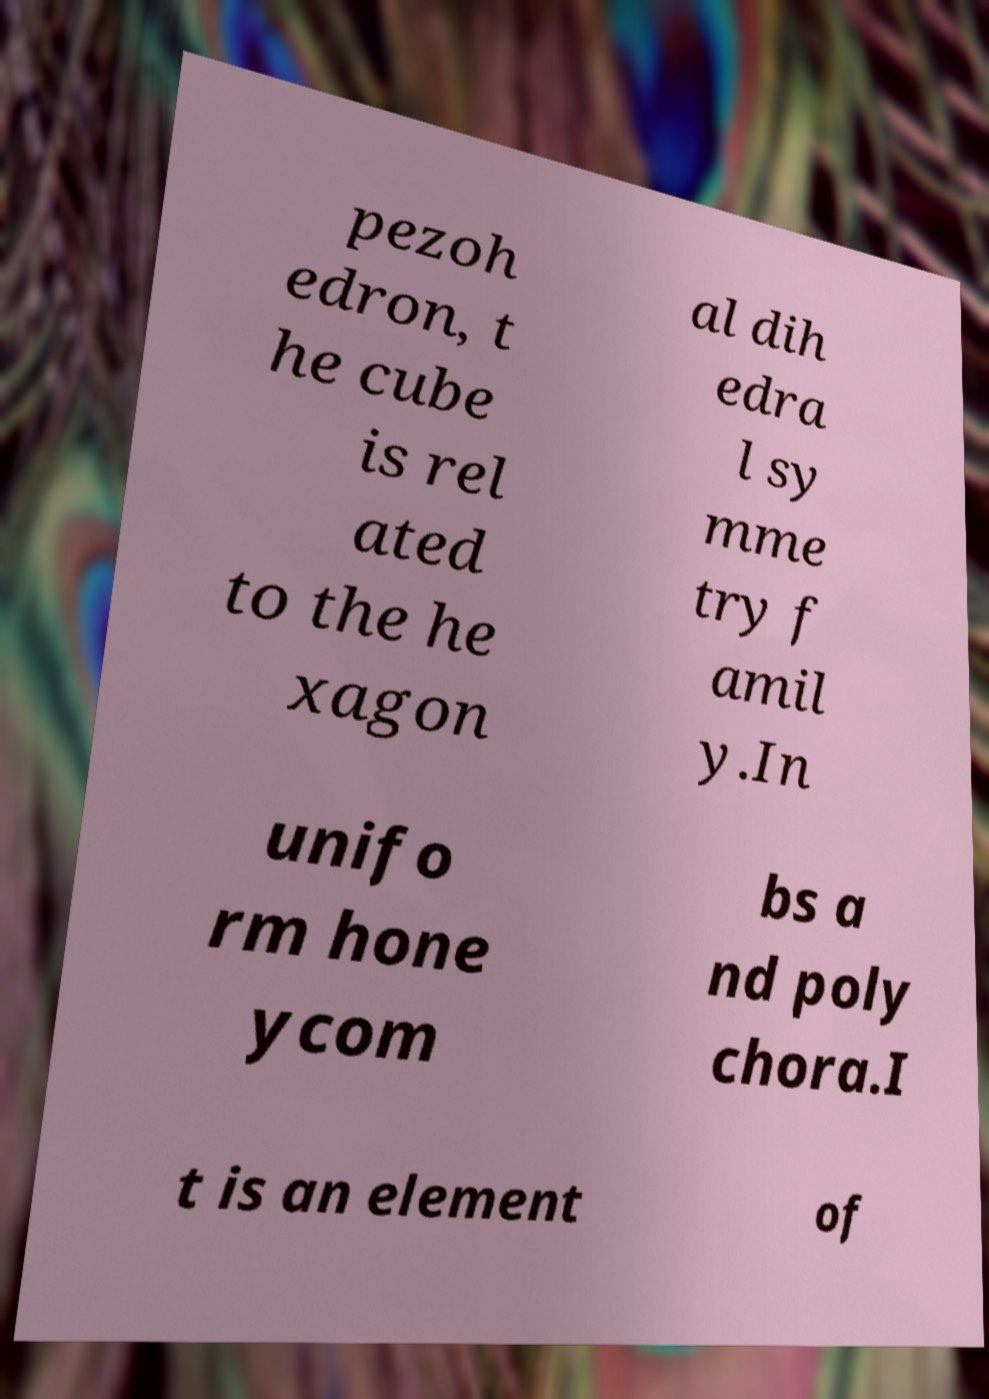There's text embedded in this image that I need extracted. Can you transcribe it verbatim? pezoh edron, t he cube is rel ated to the he xagon al dih edra l sy mme try f amil y.In unifo rm hone ycom bs a nd poly chora.I t is an element of 